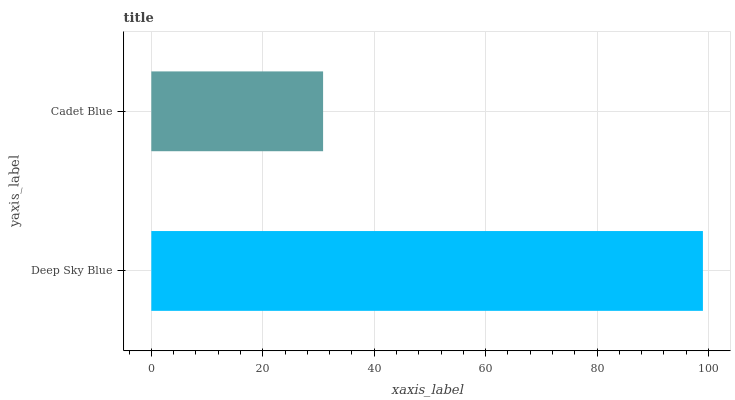Is Cadet Blue the minimum?
Answer yes or no. Yes. Is Deep Sky Blue the maximum?
Answer yes or no. Yes. Is Cadet Blue the maximum?
Answer yes or no. No. Is Deep Sky Blue greater than Cadet Blue?
Answer yes or no. Yes. Is Cadet Blue less than Deep Sky Blue?
Answer yes or no. Yes. Is Cadet Blue greater than Deep Sky Blue?
Answer yes or no. No. Is Deep Sky Blue less than Cadet Blue?
Answer yes or no. No. Is Deep Sky Blue the high median?
Answer yes or no. Yes. Is Cadet Blue the low median?
Answer yes or no. Yes. Is Cadet Blue the high median?
Answer yes or no. No. Is Deep Sky Blue the low median?
Answer yes or no. No. 